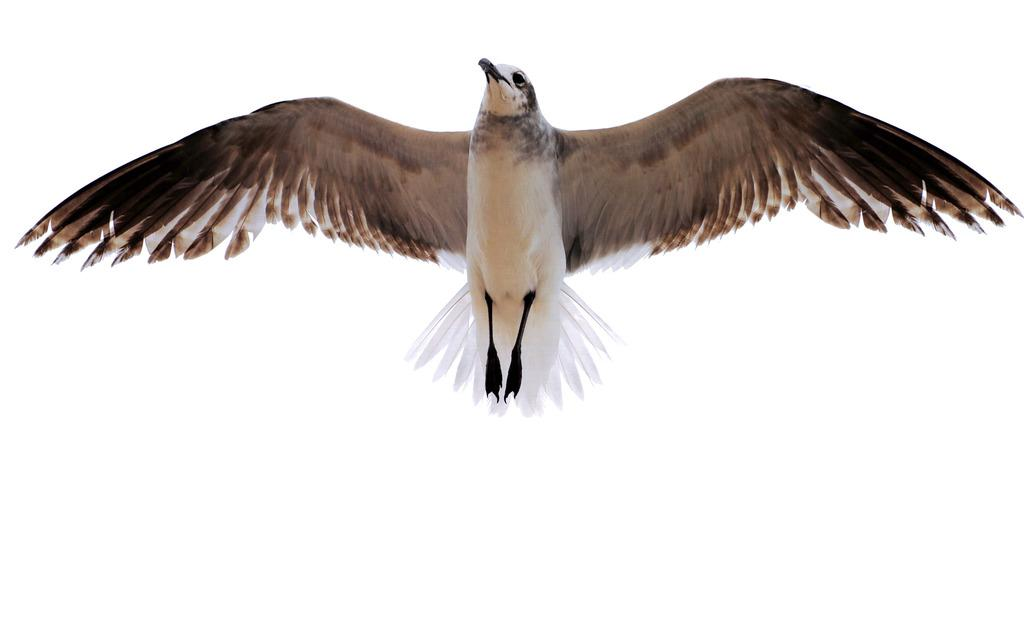What type of animal can be seen in the picture? There is a bird in the picture. What colors are present on the bird? The bird is in brown and white colors. What is the bird doing in the picture? The bird is flying in the air. What type of credit can be seen in the picture? There is no credit present in the picture; it features a bird flying in the air. Is there any popcorn visible in the picture? There is no popcorn present in the picture; it features a bird flying in the air. 